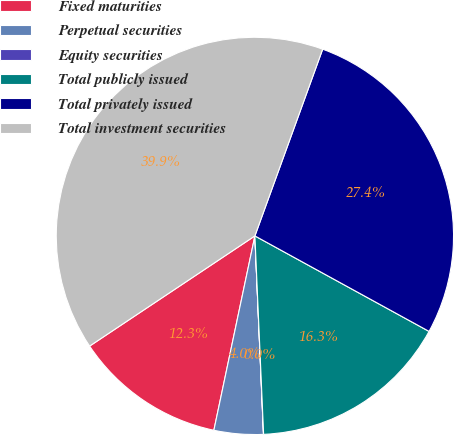<chart> <loc_0><loc_0><loc_500><loc_500><pie_chart><fcel>Fixed maturities<fcel>Perpetual securities<fcel>Equity securities<fcel>Total publicly issued<fcel>Total privately issued<fcel>Total investment securities<nl><fcel>12.33%<fcel>4.0%<fcel>0.01%<fcel>16.32%<fcel>27.44%<fcel>39.9%<nl></chart> 